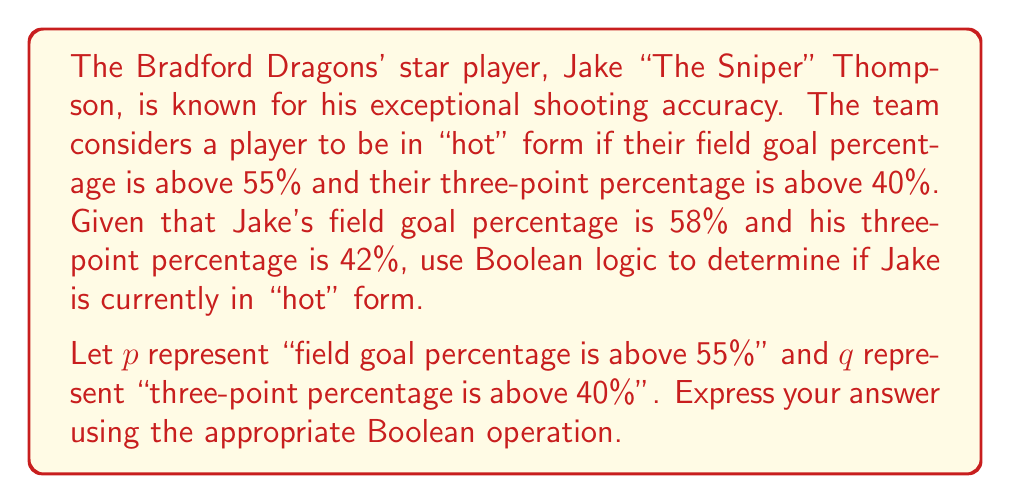Solve this math problem. To solve this problem, we need to use Boolean logic to represent the conditions and combine them appropriately.

Step 1: Define the Boolean variables
$p$: field goal percentage is above 55%
$q$: three-point percentage is above 40%

Step 2: Evaluate the truth values of $p$ and $q$
$p$: Jake's field goal percentage (58%) > 55%, so $p$ is true (1)
$q$: Jake's three-point percentage (42%) > 40%, so $q$ is true (1)

Step 3: Determine the Boolean operation
The player is considered "hot" if both conditions are met. In Boolean logic, this is represented by the AND operation, denoted by $\wedge$.

Step 4: Combine the Boolean variables
The expression to determine if Jake is in "hot" form is:
$$p \wedge q$$

Step 5: Evaluate the expression
$$p \wedge q = 1 \wedge 1 = 1$$

The result is 1 (true), which means Jake is indeed in "hot" form.
Answer: $p \wedge q = 1$ 